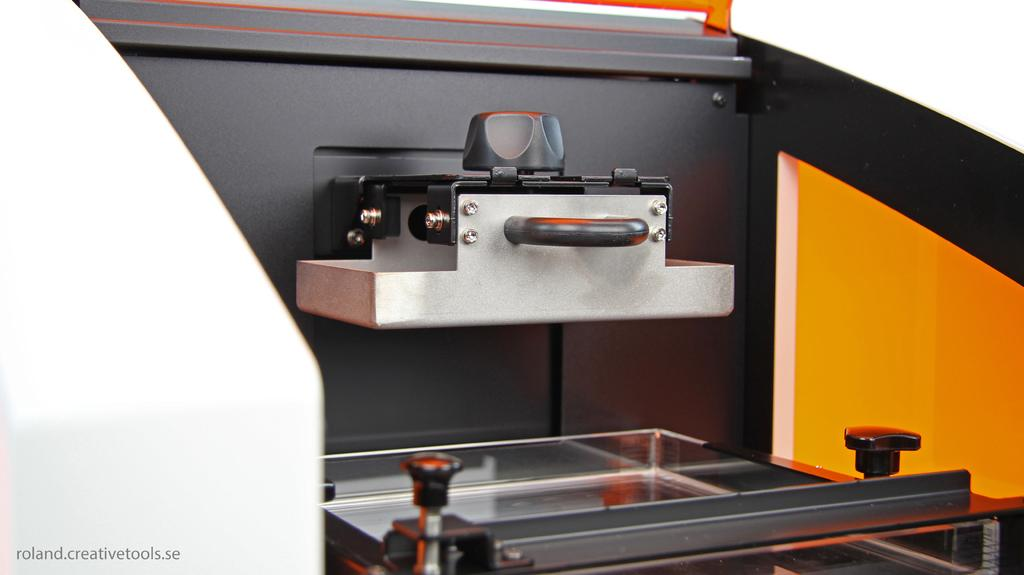What type of object has a handle in the image? The image does not show a specific object with a handle, but there is a handle present. What type of fasteners can be seen in the image? There are screws in the image. What type of interactive elements are in the image? There are buttons in the image. What type of surface is present in the image? There is a glass platform in the image. What type of frame is being used for the class event in the image? There is no frame or class event present in the image; it only shows a handle, screws, buttons, and a glass platform. 